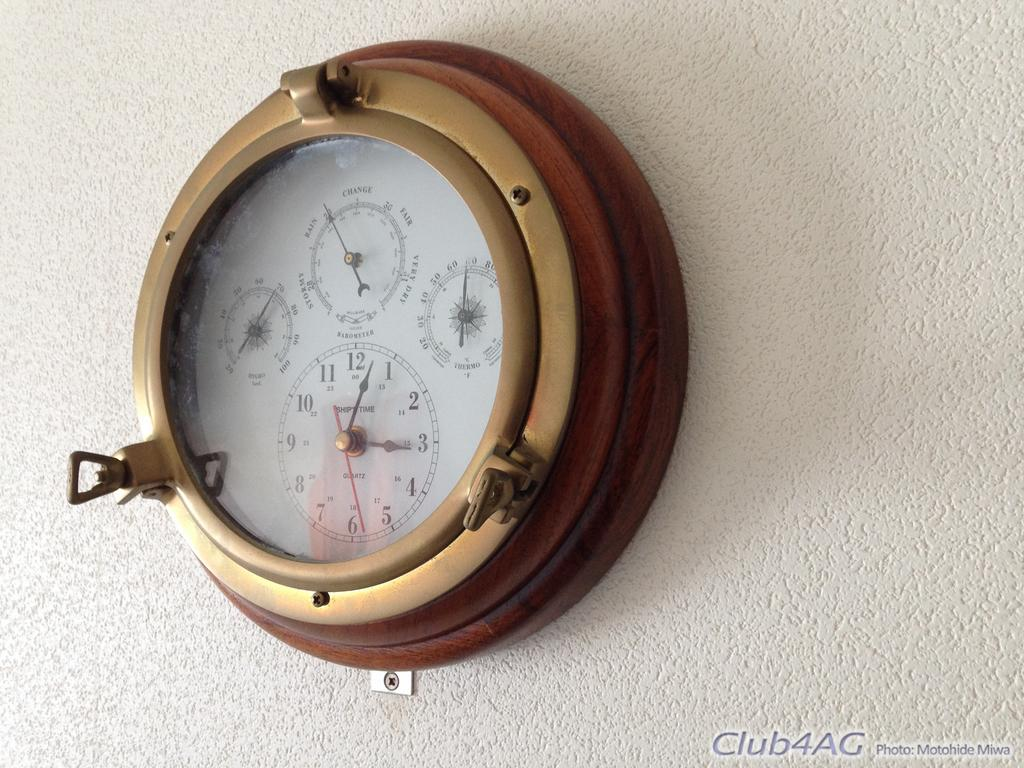Provide a one-sentence caption for the provided image. A clock with four faces points toward 3:03. 